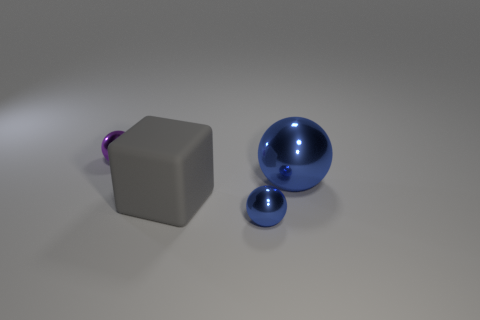There is a shiny ball in front of the rubber object; is it the same size as the gray thing?
Your response must be concise. No. Is the number of large gray matte things to the left of the tiny purple thing less than the number of big blocks?
Keep it short and to the point. Yes. What is the material of the blue object that is the same size as the gray block?
Offer a terse response. Metal. What number of large things are matte objects or blue objects?
Your answer should be very brief. 2. What number of things are either tiny objects in front of the small purple metallic object or tiny shiny spheres on the left side of the tiny blue ball?
Offer a terse response. 2. Are there fewer green cylinders than tiny blue spheres?
Provide a succinct answer. Yes. What shape is the blue object that is the same size as the purple shiny object?
Ensure brevity in your answer.  Sphere. How many other things are there of the same color as the block?
Make the answer very short. 0. What number of large gray rubber blocks are there?
Give a very brief answer. 1. How many metallic balls are to the left of the gray cube and to the right of the large rubber thing?
Offer a terse response. 0. 